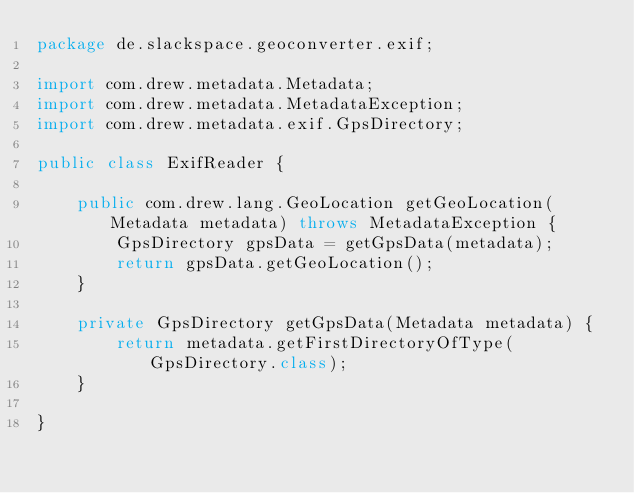<code> <loc_0><loc_0><loc_500><loc_500><_Java_>package de.slackspace.geoconverter.exif;

import com.drew.metadata.Metadata;
import com.drew.metadata.MetadataException;
import com.drew.metadata.exif.GpsDirectory;

public class ExifReader {

    public com.drew.lang.GeoLocation getGeoLocation(Metadata metadata) throws MetadataException {
        GpsDirectory gpsData = getGpsData(metadata);
        return gpsData.getGeoLocation();
    }

    private GpsDirectory getGpsData(Metadata metadata) {
        return metadata.getFirstDirectoryOfType(GpsDirectory.class);
    }

}
</code> 